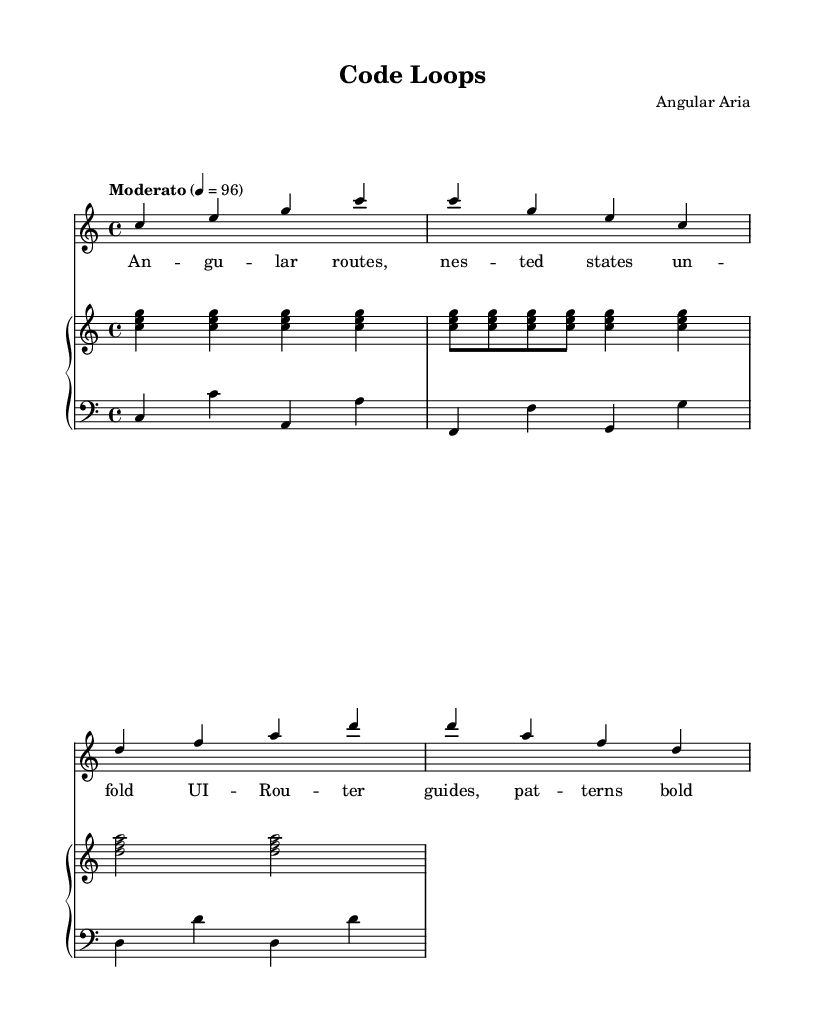What is the key signature of this music? The key signature is C major, indicated at the start of the score, which has no sharps or flats.
Answer: C major What is the time signature of this music? The time signature is 4/4, which can be found next to the key signature at the beginning of the score and indicates that there are four beats in each measure.
Answer: 4/4 What is the tempo marking of this piece? The tempo marking "Moderato" means moderate speed and is specified at the beginning of the score before the tempo indication of 96 beats per minute.
Answer: Moderato What is the name of the composer? The composer's name is listed in the header of the score, beneath the title "Code Loops."
Answer: Angular Aria How many measures are present in the soprano voice? The soprano voice has a total of 4 measures, which can be counted from the notation provided in the music.
Answer: 4 How does the piano's right hand relate to the overall structure? The piano's right hand plays a repetitive pattern, echoing a coding loop, with the same chord triads repeated throughout, creating a minimalist texture.
Answer: Repetitive What thematic elements can be identified in the lyrics? The lyrics reference concepts related to software engineering and web routing, such as "Angular routes" and "UI-Router," drawing parallels between music and coding patterns.
Answer: Software engineering themes 